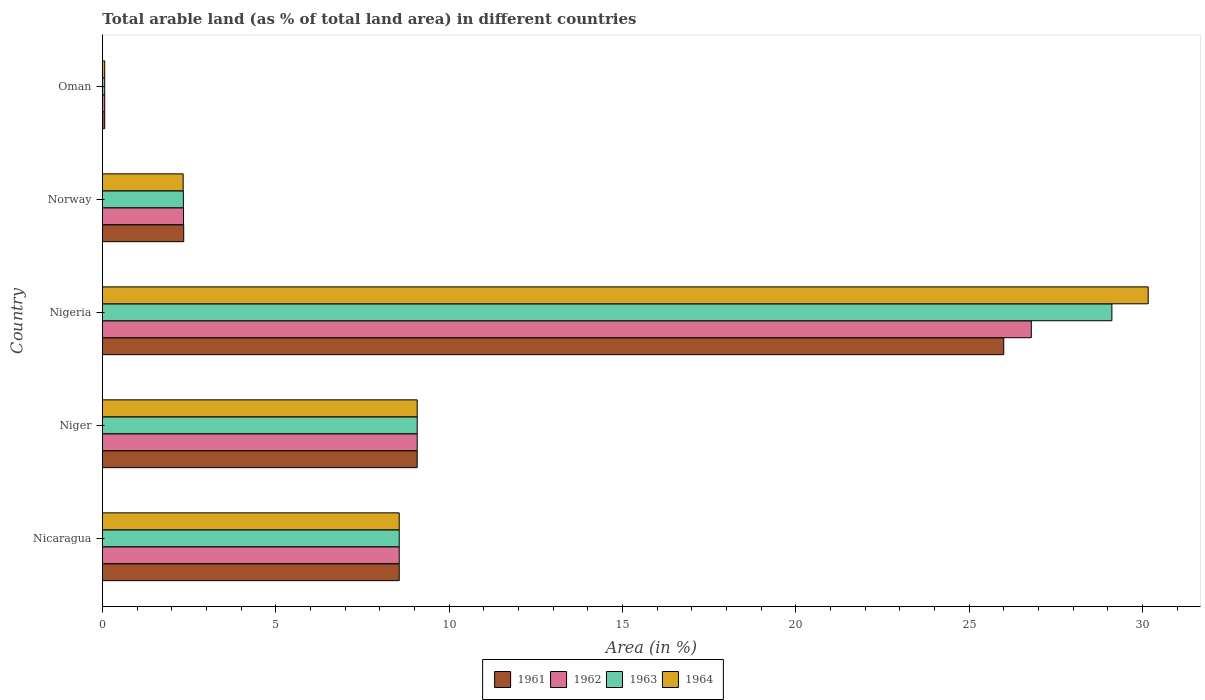How many different coloured bars are there?
Provide a succinct answer. 4. How many groups of bars are there?
Offer a very short reply. 5. Are the number of bars per tick equal to the number of legend labels?
Provide a short and direct response. Yes. Are the number of bars on each tick of the Y-axis equal?
Ensure brevity in your answer.  Yes. What is the label of the 4th group of bars from the top?
Your answer should be compact. Niger. In how many cases, is the number of bars for a given country not equal to the number of legend labels?
Make the answer very short. 0. What is the percentage of arable land in 1961 in Niger?
Your answer should be very brief. 9.08. Across all countries, what is the maximum percentage of arable land in 1961?
Offer a terse response. 26. Across all countries, what is the minimum percentage of arable land in 1961?
Keep it short and to the point. 0.06. In which country was the percentage of arable land in 1963 maximum?
Ensure brevity in your answer.  Nigeria. In which country was the percentage of arable land in 1963 minimum?
Give a very brief answer. Oman. What is the total percentage of arable land in 1962 in the graph?
Your answer should be very brief. 46.83. What is the difference between the percentage of arable land in 1962 in Nicaragua and that in Niger?
Your answer should be compact. -0.52. What is the difference between the percentage of arable land in 1963 in Nicaragua and the percentage of arable land in 1961 in Norway?
Make the answer very short. 6.22. What is the average percentage of arable land in 1964 per country?
Offer a terse response. 10.04. What is the difference between the percentage of arable land in 1961 and percentage of arable land in 1964 in Norway?
Give a very brief answer. 0.02. What is the ratio of the percentage of arable land in 1964 in Nigeria to that in Oman?
Your answer should be very brief. 466.76. Is the percentage of arable land in 1963 in Niger less than that in Nigeria?
Your answer should be very brief. Yes. Is the difference between the percentage of arable land in 1961 in Niger and Norway greater than the difference between the percentage of arable land in 1964 in Niger and Norway?
Your answer should be compact. No. What is the difference between the highest and the second highest percentage of arable land in 1964?
Provide a short and direct response. 21.08. What is the difference between the highest and the lowest percentage of arable land in 1963?
Your answer should be very brief. 29.05. In how many countries, is the percentage of arable land in 1963 greater than the average percentage of arable land in 1963 taken over all countries?
Provide a short and direct response. 1. Is the sum of the percentage of arable land in 1963 in Niger and Norway greater than the maximum percentage of arable land in 1962 across all countries?
Provide a short and direct response. No. How many countries are there in the graph?
Offer a terse response. 5. Does the graph contain grids?
Offer a very short reply. No. Where does the legend appear in the graph?
Give a very brief answer. Bottom center. How are the legend labels stacked?
Make the answer very short. Horizontal. What is the title of the graph?
Offer a very short reply. Total arable land (as % of total land area) in different countries. What is the label or title of the X-axis?
Ensure brevity in your answer.  Area (in %). What is the label or title of the Y-axis?
Ensure brevity in your answer.  Country. What is the Area (in %) in 1961 in Nicaragua?
Offer a very short reply. 8.56. What is the Area (in %) of 1962 in Nicaragua?
Give a very brief answer. 8.56. What is the Area (in %) in 1963 in Nicaragua?
Ensure brevity in your answer.  8.56. What is the Area (in %) of 1964 in Nicaragua?
Keep it short and to the point. 8.56. What is the Area (in %) in 1961 in Niger?
Provide a succinct answer. 9.08. What is the Area (in %) of 1962 in Niger?
Your answer should be very brief. 9.08. What is the Area (in %) of 1963 in Niger?
Your response must be concise. 9.08. What is the Area (in %) of 1964 in Niger?
Your answer should be very brief. 9.08. What is the Area (in %) in 1961 in Nigeria?
Your response must be concise. 26. What is the Area (in %) of 1962 in Nigeria?
Make the answer very short. 26.79. What is the Area (in %) in 1963 in Nigeria?
Make the answer very short. 29.11. What is the Area (in %) in 1964 in Nigeria?
Your answer should be very brief. 30.16. What is the Area (in %) of 1961 in Norway?
Your answer should be compact. 2.34. What is the Area (in %) in 1962 in Norway?
Offer a terse response. 2.34. What is the Area (in %) of 1963 in Norway?
Your response must be concise. 2.33. What is the Area (in %) in 1964 in Norway?
Offer a very short reply. 2.33. What is the Area (in %) in 1961 in Oman?
Make the answer very short. 0.06. What is the Area (in %) of 1962 in Oman?
Your answer should be compact. 0.06. What is the Area (in %) of 1963 in Oman?
Provide a short and direct response. 0.06. What is the Area (in %) in 1964 in Oman?
Your answer should be very brief. 0.06. Across all countries, what is the maximum Area (in %) in 1961?
Your response must be concise. 26. Across all countries, what is the maximum Area (in %) in 1962?
Make the answer very short. 26.79. Across all countries, what is the maximum Area (in %) of 1963?
Make the answer very short. 29.11. Across all countries, what is the maximum Area (in %) in 1964?
Provide a succinct answer. 30.16. Across all countries, what is the minimum Area (in %) in 1961?
Your response must be concise. 0.06. Across all countries, what is the minimum Area (in %) in 1962?
Provide a succinct answer. 0.06. Across all countries, what is the minimum Area (in %) in 1963?
Provide a short and direct response. 0.06. Across all countries, what is the minimum Area (in %) in 1964?
Offer a terse response. 0.06. What is the total Area (in %) in 1961 in the graph?
Your answer should be compact. 46.04. What is the total Area (in %) in 1962 in the graph?
Provide a short and direct response. 46.83. What is the total Area (in %) in 1963 in the graph?
Keep it short and to the point. 49.15. What is the total Area (in %) of 1964 in the graph?
Ensure brevity in your answer.  50.19. What is the difference between the Area (in %) of 1961 in Nicaragua and that in Niger?
Make the answer very short. -0.52. What is the difference between the Area (in %) of 1962 in Nicaragua and that in Niger?
Provide a short and direct response. -0.52. What is the difference between the Area (in %) in 1963 in Nicaragua and that in Niger?
Ensure brevity in your answer.  -0.52. What is the difference between the Area (in %) of 1964 in Nicaragua and that in Niger?
Make the answer very short. -0.52. What is the difference between the Area (in %) in 1961 in Nicaragua and that in Nigeria?
Your answer should be very brief. -17.44. What is the difference between the Area (in %) of 1962 in Nicaragua and that in Nigeria?
Your answer should be compact. -18.23. What is the difference between the Area (in %) in 1963 in Nicaragua and that in Nigeria?
Your answer should be compact. -20.56. What is the difference between the Area (in %) in 1964 in Nicaragua and that in Nigeria?
Keep it short and to the point. -21.6. What is the difference between the Area (in %) in 1961 in Nicaragua and that in Norway?
Offer a very short reply. 6.22. What is the difference between the Area (in %) in 1962 in Nicaragua and that in Norway?
Offer a very short reply. 6.22. What is the difference between the Area (in %) of 1963 in Nicaragua and that in Norway?
Your answer should be very brief. 6.23. What is the difference between the Area (in %) of 1964 in Nicaragua and that in Norway?
Offer a very short reply. 6.23. What is the difference between the Area (in %) of 1961 in Nicaragua and that in Oman?
Give a very brief answer. 8.49. What is the difference between the Area (in %) in 1962 in Nicaragua and that in Oman?
Offer a very short reply. 8.49. What is the difference between the Area (in %) in 1963 in Nicaragua and that in Oman?
Your answer should be compact. 8.49. What is the difference between the Area (in %) in 1964 in Nicaragua and that in Oman?
Offer a very short reply. 8.49. What is the difference between the Area (in %) in 1961 in Niger and that in Nigeria?
Ensure brevity in your answer.  -16.92. What is the difference between the Area (in %) of 1962 in Niger and that in Nigeria?
Keep it short and to the point. -17.71. What is the difference between the Area (in %) of 1963 in Niger and that in Nigeria?
Your answer should be very brief. -20.04. What is the difference between the Area (in %) of 1964 in Niger and that in Nigeria?
Your response must be concise. -21.08. What is the difference between the Area (in %) in 1961 in Niger and that in Norway?
Provide a short and direct response. 6.73. What is the difference between the Area (in %) in 1962 in Niger and that in Norway?
Provide a short and direct response. 6.74. What is the difference between the Area (in %) of 1963 in Niger and that in Norway?
Provide a short and direct response. 6.75. What is the difference between the Area (in %) in 1964 in Niger and that in Norway?
Offer a very short reply. 6.75. What is the difference between the Area (in %) of 1961 in Niger and that in Oman?
Keep it short and to the point. 9.01. What is the difference between the Area (in %) in 1962 in Niger and that in Oman?
Your response must be concise. 9.01. What is the difference between the Area (in %) of 1963 in Niger and that in Oman?
Your response must be concise. 9.01. What is the difference between the Area (in %) in 1964 in Niger and that in Oman?
Provide a succinct answer. 9.01. What is the difference between the Area (in %) in 1961 in Nigeria and that in Norway?
Provide a succinct answer. 23.65. What is the difference between the Area (in %) of 1962 in Nigeria and that in Norway?
Provide a short and direct response. 24.45. What is the difference between the Area (in %) in 1963 in Nigeria and that in Norway?
Your answer should be very brief. 26.78. What is the difference between the Area (in %) of 1964 in Nigeria and that in Norway?
Make the answer very short. 27.84. What is the difference between the Area (in %) in 1961 in Nigeria and that in Oman?
Keep it short and to the point. 25.93. What is the difference between the Area (in %) in 1962 in Nigeria and that in Oman?
Your response must be concise. 26.73. What is the difference between the Area (in %) of 1963 in Nigeria and that in Oman?
Your response must be concise. 29.05. What is the difference between the Area (in %) of 1964 in Nigeria and that in Oman?
Give a very brief answer. 30.1. What is the difference between the Area (in %) in 1961 in Norway and that in Oman?
Keep it short and to the point. 2.28. What is the difference between the Area (in %) of 1962 in Norway and that in Oman?
Keep it short and to the point. 2.27. What is the difference between the Area (in %) in 1963 in Norway and that in Oman?
Keep it short and to the point. 2.27. What is the difference between the Area (in %) of 1964 in Norway and that in Oman?
Provide a succinct answer. 2.26. What is the difference between the Area (in %) in 1961 in Nicaragua and the Area (in %) in 1962 in Niger?
Offer a terse response. -0.52. What is the difference between the Area (in %) in 1961 in Nicaragua and the Area (in %) in 1963 in Niger?
Make the answer very short. -0.52. What is the difference between the Area (in %) in 1961 in Nicaragua and the Area (in %) in 1964 in Niger?
Your response must be concise. -0.52. What is the difference between the Area (in %) in 1962 in Nicaragua and the Area (in %) in 1963 in Niger?
Your response must be concise. -0.52. What is the difference between the Area (in %) in 1962 in Nicaragua and the Area (in %) in 1964 in Niger?
Ensure brevity in your answer.  -0.52. What is the difference between the Area (in %) of 1963 in Nicaragua and the Area (in %) of 1964 in Niger?
Your answer should be very brief. -0.52. What is the difference between the Area (in %) in 1961 in Nicaragua and the Area (in %) in 1962 in Nigeria?
Your answer should be compact. -18.23. What is the difference between the Area (in %) in 1961 in Nicaragua and the Area (in %) in 1963 in Nigeria?
Ensure brevity in your answer.  -20.56. What is the difference between the Area (in %) in 1961 in Nicaragua and the Area (in %) in 1964 in Nigeria?
Offer a terse response. -21.6. What is the difference between the Area (in %) in 1962 in Nicaragua and the Area (in %) in 1963 in Nigeria?
Keep it short and to the point. -20.56. What is the difference between the Area (in %) in 1962 in Nicaragua and the Area (in %) in 1964 in Nigeria?
Your answer should be compact. -21.6. What is the difference between the Area (in %) of 1963 in Nicaragua and the Area (in %) of 1964 in Nigeria?
Make the answer very short. -21.6. What is the difference between the Area (in %) in 1961 in Nicaragua and the Area (in %) in 1962 in Norway?
Offer a very short reply. 6.22. What is the difference between the Area (in %) of 1961 in Nicaragua and the Area (in %) of 1963 in Norway?
Offer a terse response. 6.23. What is the difference between the Area (in %) in 1961 in Nicaragua and the Area (in %) in 1964 in Norway?
Offer a terse response. 6.23. What is the difference between the Area (in %) in 1962 in Nicaragua and the Area (in %) in 1963 in Norway?
Your response must be concise. 6.23. What is the difference between the Area (in %) in 1962 in Nicaragua and the Area (in %) in 1964 in Norway?
Your response must be concise. 6.23. What is the difference between the Area (in %) in 1963 in Nicaragua and the Area (in %) in 1964 in Norway?
Your answer should be compact. 6.23. What is the difference between the Area (in %) of 1961 in Nicaragua and the Area (in %) of 1962 in Oman?
Make the answer very short. 8.49. What is the difference between the Area (in %) of 1961 in Nicaragua and the Area (in %) of 1963 in Oman?
Provide a short and direct response. 8.49. What is the difference between the Area (in %) in 1961 in Nicaragua and the Area (in %) in 1964 in Oman?
Provide a succinct answer. 8.49. What is the difference between the Area (in %) in 1962 in Nicaragua and the Area (in %) in 1963 in Oman?
Provide a short and direct response. 8.49. What is the difference between the Area (in %) of 1962 in Nicaragua and the Area (in %) of 1964 in Oman?
Ensure brevity in your answer.  8.49. What is the difference between the Area (in %) of 1963 in Nicaragua and the Area (in %) of 1964 in Oman?
Your answer should be very brief. 8.49. What is the difference between the Area (in %) of 1961 in Niger and the Area (in %) of 1962 in Nigeria?
Ensure brevity in your answer.  -17.71. What is the difference between the Area (in %) of 1961 in Niger and the Area (in %) of 1963 in Nigeria?
Give a very brief answer. -20.04. What is the difference between the Area (in %) in 1961 in Niger and the Area (in %) in 1964 in Nigeria?
Ensure brevity in your answer.  -21.08. What is the difference between the Area (in %) in 1962 in Niger and the Area (in %) in 1963 in Nigeria?
Make the answer very short. -20.04. What is the difference between the Area (in %) of 1962 in Niger and the Area (in %) of 1964 in Nigeria?
Your answer should be very brief. -21.08. What is the difference between the Area (in %) in 1963 in Niger and the Area (in %) in 1964 in Nigeria?
Your response must be concise. -21.08. What is the difference between the Area (in %) of 1961 in Niger and the Area (in %) of 1962 in Norway?
Your answer should be very brief. 6.74. What is the difference between the Area (in %) of 1961 in Niger and the Area (in %) of 1963 in Norway?
Make the answer very short. 6.75. What is the difference between the Area (in %) in 1961 in Niger and the Area (in %) in 1964 in Norway?
Offer a very short reply. 6.75. What is the difference between the Area (in %) in 1962 in Niger and the Area (in %) in 1963 in Norway?
Give a very brief answer. 6.75. What is the difference between the Area (in %) of 1962 in Niger and the Area (in %) of 1964 in Norway?
Provide a short and direct response. 6.75. What is the difference between the Area (in %) in 1963 in Niger and the Area (in %) in 1964 in Norway?
Your answer should be compact. 6.75. What is the difference between the Area (in %) in 1961 in Niger and the Area (in %) in 1962 in Oman?
Provide a short and direct response. 9.01. What is the difference between the Area (in %) in 1961 in Niger and the Area (in %) in 1963 in Oman?
Make the answer very short. 9.01. What is the difference between the Area (in %) in 1961 in Niger and the Area (in %) in 1964 in Oman?
Give a very brief answer. 9.01. What is the difference between the Area (in %) in 1962 in Niger and the Area (in %) in 1963 in Oman?
Your answer should be very brief. 9.01. What is the difference between the Area (in %) of 1962 in Niger and the Area (in %) of 1964 in Oman?
Keep it short and to the point. 9.01. What is the difference between the Area (in %) of 1963 in Niger and the Area (in %) of 1964 in Oman?
Make the answer very short. 9.01. What is the difference between the Area (in %) in 1961 in Nigeria and the Area (in %) in 1962 in Norway?
Provide a succinct answer. 23.66. What is the difference between the Area (in %) in 1961 in Nigeria and the Area (in %) in 1963 in Norway?
Your answer should be compact. 23.66. What is the difference between the Area (in %) in 1961 in Nigeria and the Area (in %) in 1964 in Norway?
Give a very brief answer. 23.67. What is the difference between the Area (in %) in 1962 in Nigeria and the Area (in %) in 1963 in Norway?
Keep it short and to the point. 24.46. What is the difference between the Area (in %) of 1962 in Nigeria and the Area (in %) of 1964 in Norway?
Offer a very short reply. 24.46. What is the difference between the Area (in %) in 1963 in Nigeria and the Area (in %) in 1964 in Norway?
Make the answer very short. 26.79. What is the difference between the Area (in %) of 1961 in Nigeria and the Area (in %) of 1962 in Oman?
Provide a short and direct response. 25.93. What is the difference between the Area (in %) of 1961 in Nigeria and the Area (in %) of 1963 in Oman?
Make the answer very short. 25.93. What is the difference between the Area (in %) in 1961 in Nigeria and the Area (in %) in 1964 in Oman?
Your response must be concise. 25.93. What is the difference between the Area (in %) in 1962 in Nigeria and the Area (in %) in 1963 in Oman?
Your answer should be very brief. 26.73. What is the difference between the Area (in %) of 1962 in Nigeria and the Area (in %) of 1964 in Oman?
Provide a succinct answer. 26.73. What is the difference between the Area (in %) in 1963 in Nigeria and the Area (in %) in 1964 in Oman?
Make the answer very short. 29.05. What is the difference between the Area (in %) in 1961 in Norway and the Area (in %) in 1962 in Oman?
Ensure brevity in your answer.  2.28. What is the difference between the Area (in %) of 1961 in Norway and the Area (in %) of 1963 in Oman?
Give a very brief answer. 2.28. What is the difference between the Area (in %) of 1961 in Norway and the Area (in %) of 1964 in Oman?
Make the answer very short. 2.28. What is the difference between the Area (in %) in 1962 in Norway and the Area (in %) in 1963 in Oman?
Offer a terse response. 2.27. What is the difference between the Area (in %) of 1962 in Norway and the Area (in %) of 1964 in Oman?
Make the answer very short. 2.27. What is the difference between the Area (in %) of 1963 in Norway and the Area (in %) of 1964 in Oman?
Keep it short and to the point. 2.27. What is the average Area (in %) of 1961 per country?
Provide a short and direct response. 9.21. What is the average Area (in %) of 1962 per country?
Provide a short and direct response. 9.37. What is the average Area (in %) in 1963 per country?
Keep it short and to the point. 9.83. What is the average Area (in %) of 1964 per country?
Make the answer very short. 10.04. What is the difference between the Area (in %) in 1961 and Area (in %) in 1963 in Nicaragua?
Offer a terse response. 0. What is the difference between the Area (in %) of 1961 and Area (in %) of 1964 in Nicaragua?
Make the answer very short. 0. What is the difference between the Area (in %) in 1963 and Area (in %) in 1964 in Nicaragua?
Provide a short and direct response. 0. What is the difference between the Area (in %) in 1962 and Area (in %) in 1963 in Niger?
Ensure brevity in your answer.  0. What is the difference between the Area (in %) in 1963 and Area (in %) in 1964 in Niger?
Offer a very short reply. 0. What is the difference between the Area (in %) of 1961 and Area (in %) of 1962 in Nigeria?
Your answer should be very brief. -0.79. What is the difference between the Area (in %) in 1961 and Area (in %) in 1963 in Nigeria?
Ensure brevity in your answer.  -3.12. What is the difference between the Area (in %) in 1961 and Area (in %) in 1964 in Nigeria?
Make the answer very short. -4.17. What is the difference between the Area (in %) of 1962 and Area (in %) of 1963 in Nigeria?
Offer a terse response. -2.32. What is the difference between the Area (in %) of 1962 and Area (in %) of 1964 in Nigeria?
Your answer should be compact. -3.37. What is the difference between the Area (in %) of 1963 and Area (in %) of 1964 in Nigeria?
Make the answer very short. -1.05. What is the difference between the Area (in %) of 1961 and Area (in %) of 1962 in Norway?
Offer a very short reply. 0.01. What is the difference between the Area (in %) of 1961 and Area (in %) of 1963 in Norway?
Provide a succinct answer. 0.01. What is the difference between the Area (in %) of 1961 and Area (in %) of 1964 in Norway?
Provide a short and direct response. 0.02. What is the difference between the Area (in %) of 1962 and Area (in %) of 1963 in Norway?
Offer a terse response. 0.01. What is the difference between the Area (in %) in 1962 and Area (in %) in 1964 in Norway?
Provide a succinct answer. 0.01. What is the difference between the Area (in %) of 1963 and Area (in %) of 1964 in Norway?
Ensure brevity in your answer.  0.01. What is the difference between the Area (in %) in 1961 and Area (in %) in 1963 in Oman?
Provide a short and direct response. 0. What is the difference between the Area (in %) in 1961 and Area (in %) in 1964 in Oman?
Provide a short and direct response. 0. What is the difference between the Area (in %) in 1963 and Area (in %) in 1964 in Oman?
Offer a terse response. 0. What is the ratio of the Area (in %) of 1961 in Nicaragua to that in Niger?
Offer a very short reply. 0.94. What is the ratio of the Area (in %) in 1962 in Nicaragua to that in Niger?
Offer a very short reply. 0.94. What is the ratio of the Area (in %) of 1963 in Nicaragua to that in Niger?
Offer a terse response. 0.94. What is the ratio of the Area (in %) in 1964 in Nicaragua to that in Niger?
Your answer should be compact. 0.94. What is the ratio of the Area (in %) of 1961 in Nicaragua to that in Nigeria?
Offer a terse response. 0.33. What is the ratio of the Area (in %) of 1962 in Nicaragua to that in Nigeria?
Your response must be concise. 0.32. What is the ratio of the Area (in %) in 1963 in Nicaragua to that in Nigeria?
Provide a succinct answer. 0.29. What is the ratio of the Area (in %) in 1964 in Nicaragua to that in Nigeria?
Offer a very short reply. 0.28. What is the ratio of the Area (in %) of 1961 in Nicaragua to that in Norway?
Offer a very short reply. 3.65. What is the ratio of the Area (in %) in 1962 in Nicaragua to that in Norway?
Offer a terse response. 3.66. What is the ratio of the Area (in %) of 1963 in Nicaragua to that in Norway?
Make the answer very short. 3.67. What is the ratio of the Area (in %) of 1964 in Nicaragua to that in Norway?
Make the answer very short. 3.68. What is the ratio of the Area (in %) in 1961 in Nicaragua to that in Oman?
Provide a short and direct response. 132.45. What is the ratio of the Area (in %) in 1962 in Nicaragua to that in Oman?
Provide a succinct answer. 132.45. What is the ratio of the Area (in %) of 1963 in Nicaragua to that in Oman?
Your response must be concise. 132.45. What is the ratio of the Area (in %) in 1964 in Nicaragua to that in Oman?
Offer a very short reply. 132.45. What is the ratio of the Area (in %) in 1961 in Niger to that in Nigeria?
Your answer should be very brief. 0.35. What is the ratio of the Area (in %) of 1962 in Niger to that in Nigeria?
Make the answer very short. 0.34. What is the ratio of the Area (in %) in 1963 in Niger to that in Nigeria?
Your answer should be very brief. 0.31. What is the ratio of the Area (in %) of 1964 in Niger to that in Nigeria?
Keep it short and to the point. 0.3. What is the ratio of the Area (in %) of 1961 in Niger to that in Norway?
Offer a very short reply. 3.87. What is the ratio of the Area (in %) in 1962 in Niger to that in Norway?
Offer a very short reply. 3.88. What is the ratio of the Area (in %) in 1963 in Niger to that in Norway?
Provide a short and direct response. 3.89. What is the ratio of the Area (in %) in 1964 in Niger to that in Norway?
Your answer should be very brief. 3.9. What is the ratio of the Area (in %) of 1961 in Niger to that in Oman?
Keep it short and to the point. 140.48. What is the ratio of the Area (in %) of 1962 in Niger to that in Oman?
Ensure brevity in your answer.  140.48. What is the ratio of the Area (in %) of 1963 in Niger to that in Oman?
Make the answer very short. 140.48. What is the ratio of the Area (in %) in 1964 in Niger to that in Oman?
Offer a very short reply. 140.48. What is the ratio of the Area (in %) in 1961 in Nigeria to that in Norway?
Keep it short and to the point. 11.09. What is the ratio of the Area (in %) in 1962 in Nigeria to that in Norway?
Give a very brief answer. 11.46. What is the ratio of the Area (in %) in 1963 in Nigeria to that in Norway?
Make the answer very short. 12.48. What is the ratio of the Area (in %) in 1964 in Nigeria to that in Norway?
Provide a short and direct response. 12.96. What is the ratio of the Area (in %) in 1961 in Nigeria to that in Oman?
Provide a succinct answer. 402.29. What is the ratio of the Area (in %) of 1962 in Nigeria to that in Oman?
Provide a succinct answer. 414.58. What is the ratio of the Area (in %) in 1963 in Nigeria to that in Oman?
Give a very brief answer. 450.55. What is the ratio of the Area (in %) in 1964 in Nigeria to that in Oman?
Keep it short and to the point. 466.76. What is the ratio of the Area (in %) of 1961 in Norway to that in Oman?
Provide a succinct answer. 36.27. What is the ratio of the Area (in %) in 1962 in Norway to that in Oman?
Keep it short and to the point. 36.18. What is the ratio of the Area (in %) of 1963 in Norway to that in Oman?
Offer a terse response. 36.1. What is the ratio of the Area (in %) of 1964 in Norway to that in Oman?
Make the answer very short. 36.01. What is the difference between the highest and the second highest Area (in %) in 1961?
Your answer should be compact. 16.92. What is the difference between the highest and the second highest Area (in %) in 1962?
Your answer should be compact. 17.71. What is the difference between the highest and the second highest Area (in %) in 1963?
Make the answer very short. 20.04. What is the difference between the highest and the second highest Area (in %) of 1964?
Your response must be concise. 21.08. What is the difference between the highest and the lowest Area (in %) of 1961?
Offer a very short reply. 25.93. What is the difference between the highest and the lowest Area (in %) in 1962?
Your response must be concise. 26.73. What is the difference between the highest and the lowest Area (in %) of 1963?
Provide a succinct answer. 29.05. What is the difference between the highest and the lowest Area (in %) in 1964?
Offer a very short reply. 30.1. 